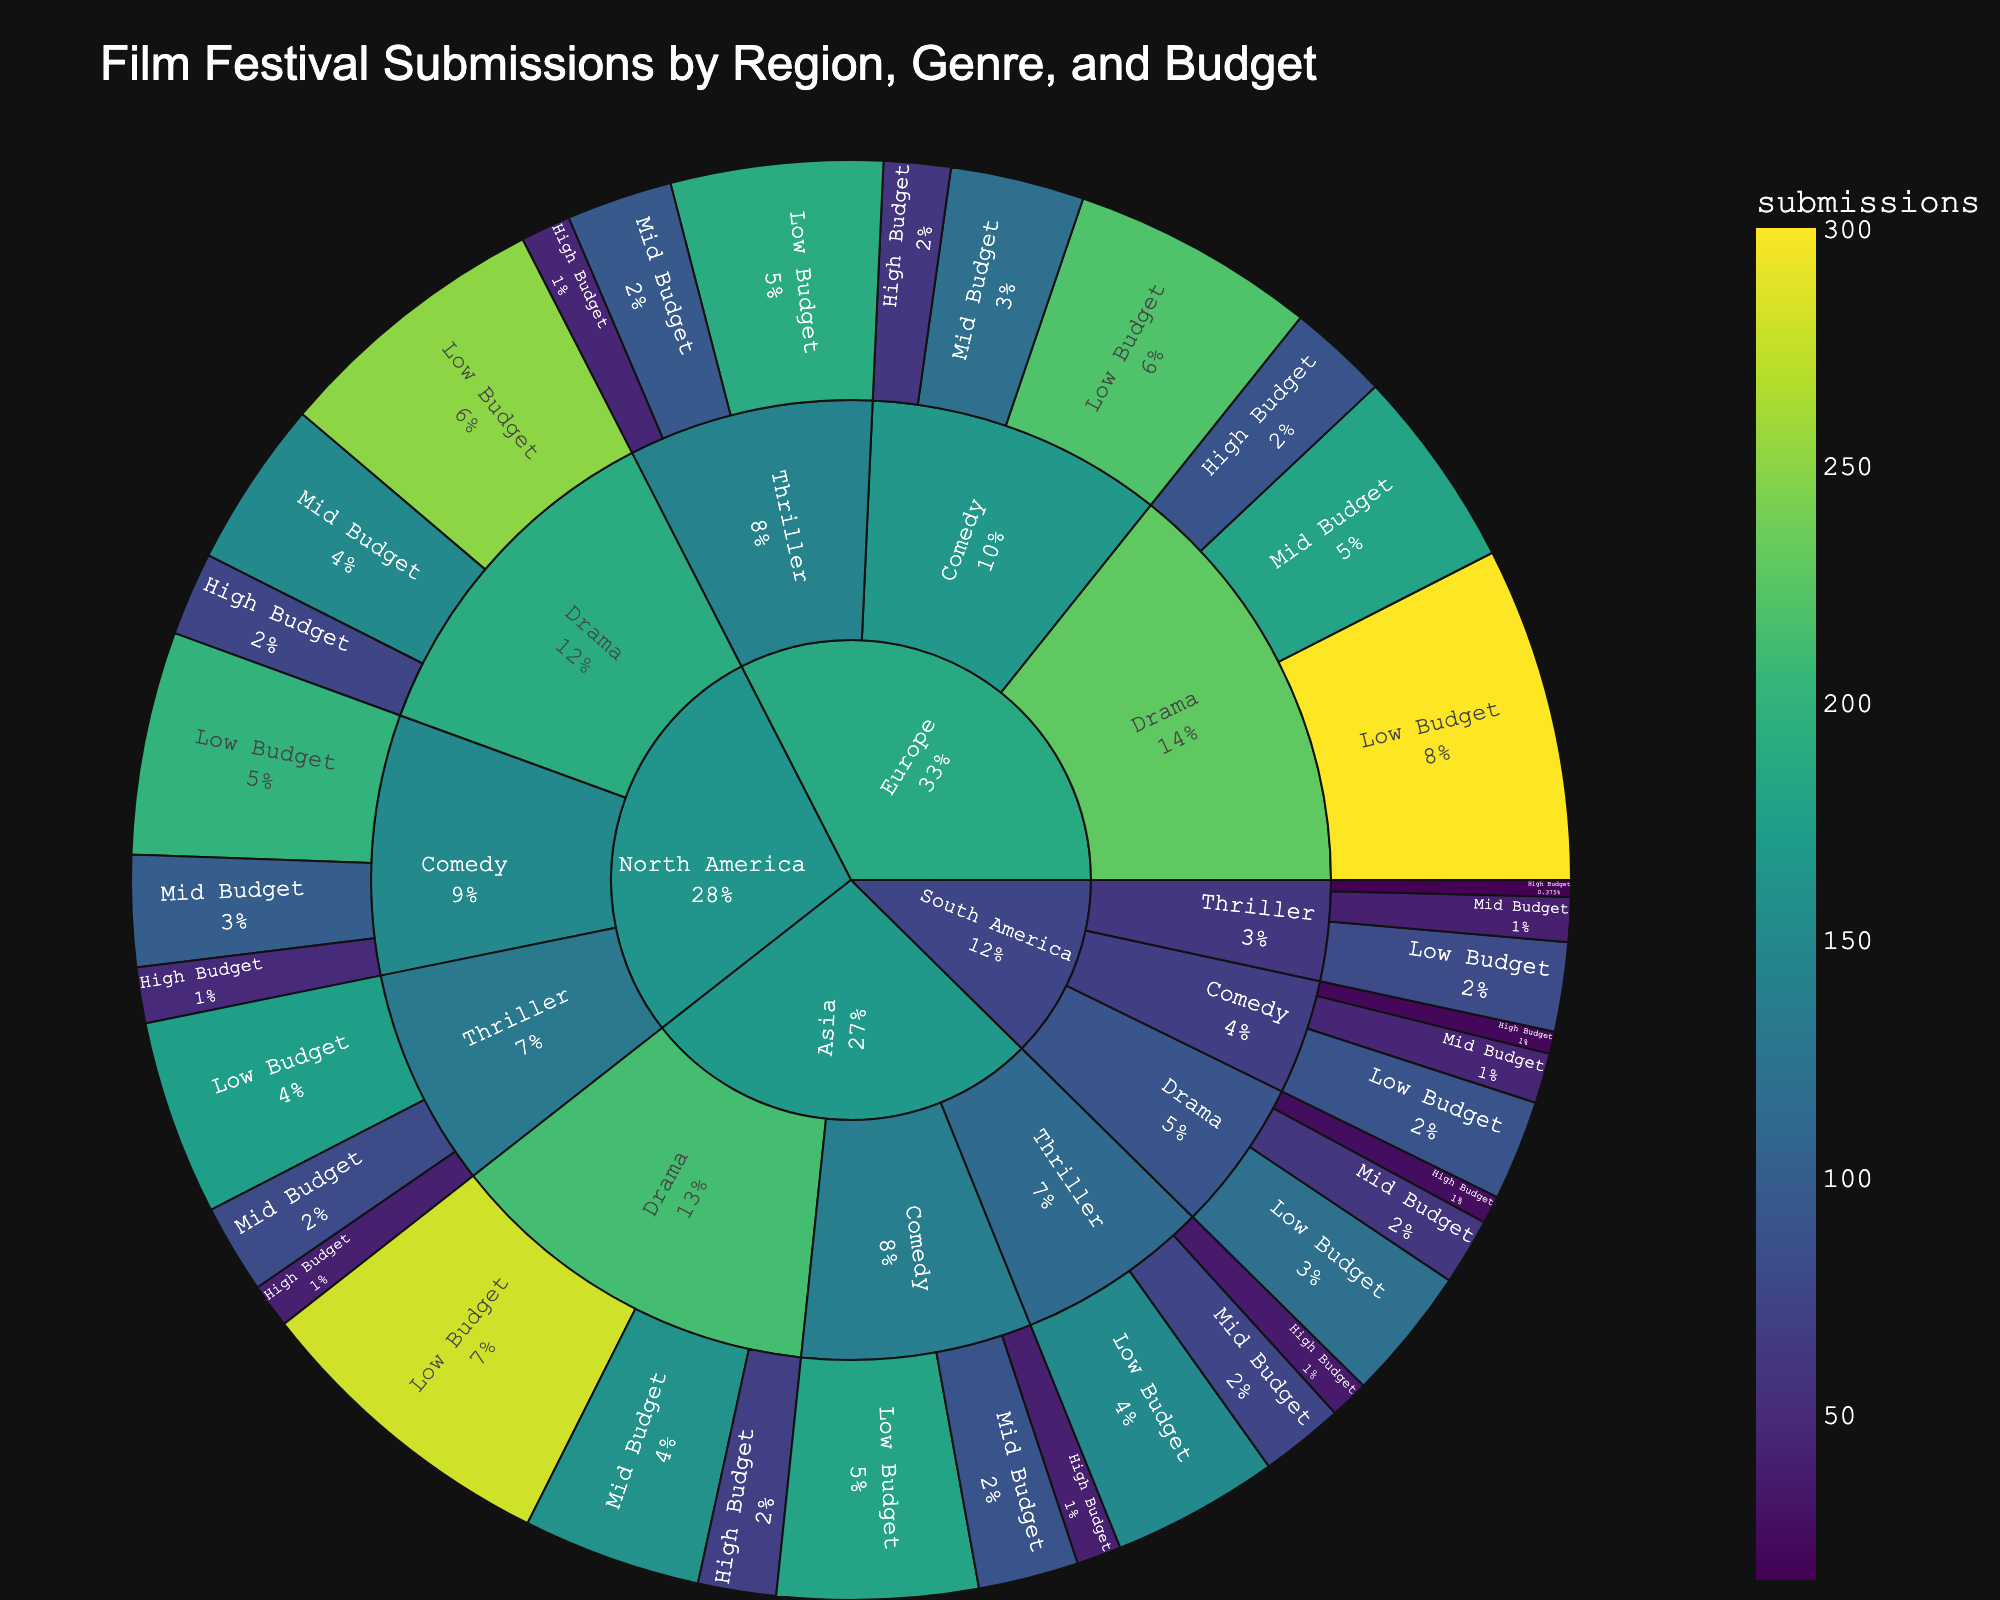what is the title of the figure? The title is usually located at the top center of the figure and displayed in a larger font size than other text elements. It details the main subject of the chart.
Answer: Film Festival Submissions by Region, Genre, and Budget Which region has the most film submissions? By looking at the plot, observe the size of the sections in the outermost ring corresponding to each region. The region with the largest combined section (outermost ring) will have the most submissions.
Answer: Europe Within the Drama genre, which region has the highest number of low budget submissions? Focus on the Drama genre segments and compare the sizes of the Low Budget sections within each region.
Answer: Europe For North America, what is the total number of submissions across all genres and budget sizes? Sum the submissions for all genres and budget sizes within the North America region. The values are: 250 (Drama, Low Budget) + 150 (Drama, Mid Budget) + 75 (Drama, High Budget) + 200 (Comedy, Low Budget) + 100 (Comedy, Mid Budget) + 50 (Comedy, High Budget) + 175 (Thriller, Low Budget) + 80 (Thriller, Mid Budget) + 40 (Thriller, High Budget).
Answer: 1120 Compare the total submissions of High Budget films in Comedy between Europe and Asia. Which region has more submissions? Locate the High Budget Comedy segments for both Europe and Asia regions and compare the number of submissions. Europe has 60 submissions, while Asia has 40.
Answer: Europe Which genre has the least total submissions in South America? Compare the total submissions for Drama, Comedy, and Thriller by summing their respective submissions across all budget sizes in the South America region. Lowest total will indicate the genre with the least submissions.
Answer: Thriller What percentage of the total Drama submissions are High Budget films in Asia? First, find the total Drama submissions in Asia: 280 (Low Budget) + 160 (Mid Budget) + 70 (High Budget) = 510. Then, calculate the percentage of High Budget: (70/510) * 100.
Answer: ~13.73% In terms of Mid Budget Comedy submissions, how does North America compare with South America? Identify the Mid Budget Comedy segments for North America (100 submissions) and South America (45 submissions) and compare their values.
Answer: North America has more What is the combined total of all submissions for the Thriller genre? Sum the submissions for the Thriller genre across all regions and budget sizes. Total = (175+80+40)+(190+95+45)+(150+75+35)+(80+40+15).
Answer: 1015 